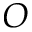<formula> <loc_0><loc_0><loc_500><loc_500>O</formula> 